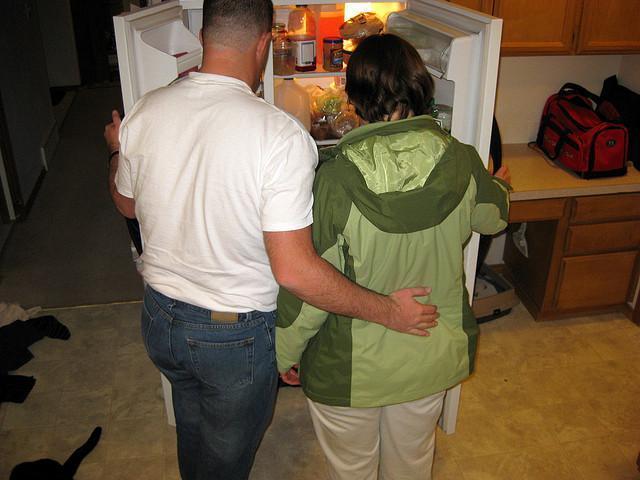How many people are there?
Give a very brief answer. 2. How many refrigerators can be seen?
Give a very brief answer. 1. 